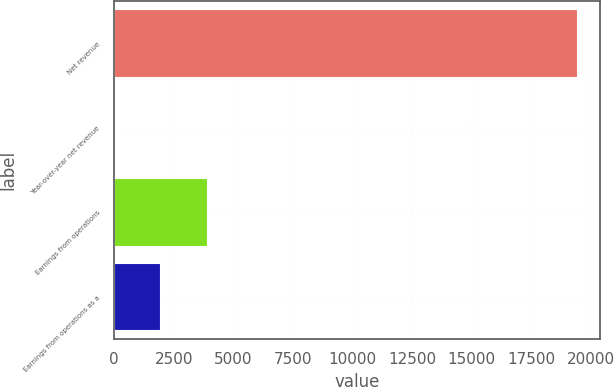<chart> <loc_0><loc_0><loc_500><loc_500><bar_chart><fcel>Net revenue<fcel>Year-over-year net revenue<fcel>Earnings from operations<fcel>Earnings from operations as a<nl><fcel>19400<fcel>4.1<fcel>3883.28<fcel>1943.69<nl></chart> 